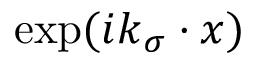Convert formula to latex. <formula><loc_0><loc_0><loc_500><loc_500>\exp ( i k _ { \sigma } \cdot x )</formula> 